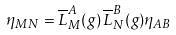Convert formula to latex. <formula><loc_0><loc_0><loc_500><loc_500>\eta _ { M N } = \overline { L } ^ { A } _ { M } ( g ) \, \overline { L } ^ { B } _ { N } ( g ) \eta _ { A B }</formula> 